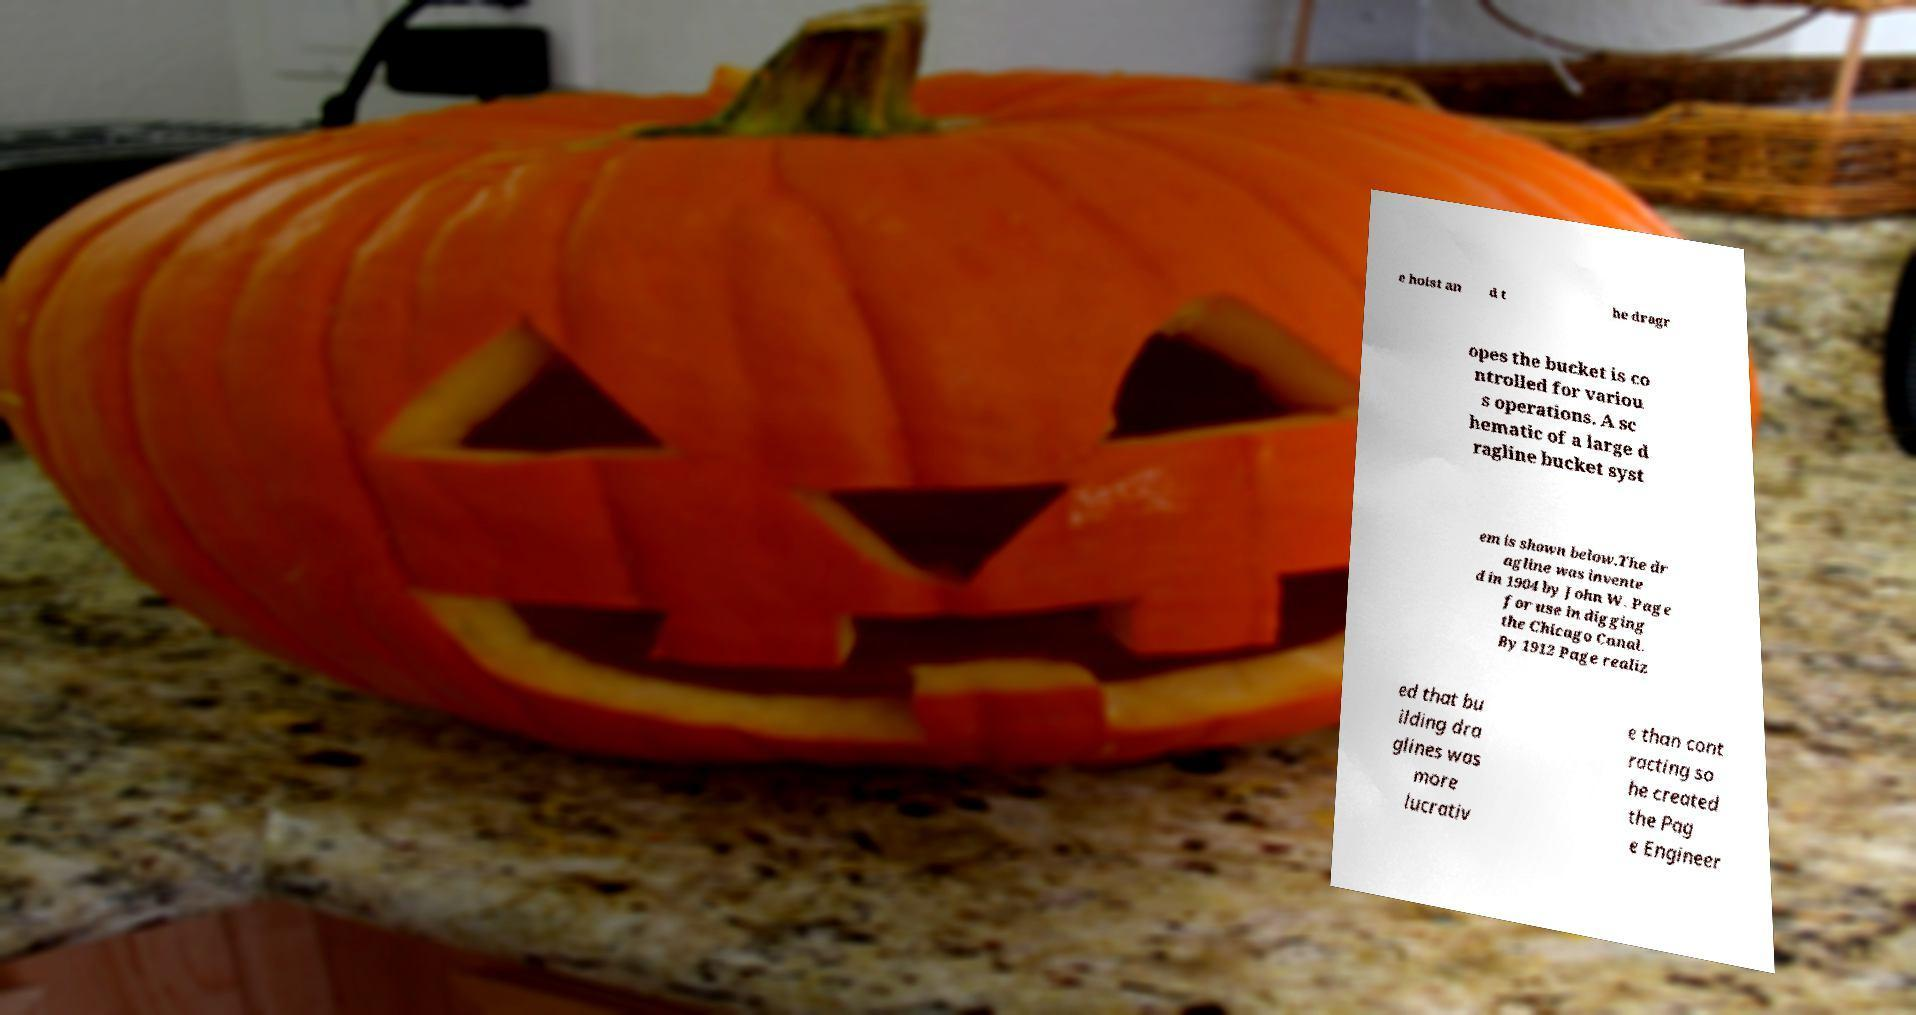Please read and relay the text visible in this image. What does it say? e hoist an d t he dragr opes the bucket is co ntrolled for variou s operations. A sc hematic of a large d ragline bucket syst em is shown below.The dr agline was invente d in 1904 by John W. Page for use in digging the Chicago Canal. By 1912 Page realiz ed that bu ilding dra glines was more lucrativ e than cont racting so he created the Pag e Engineer 